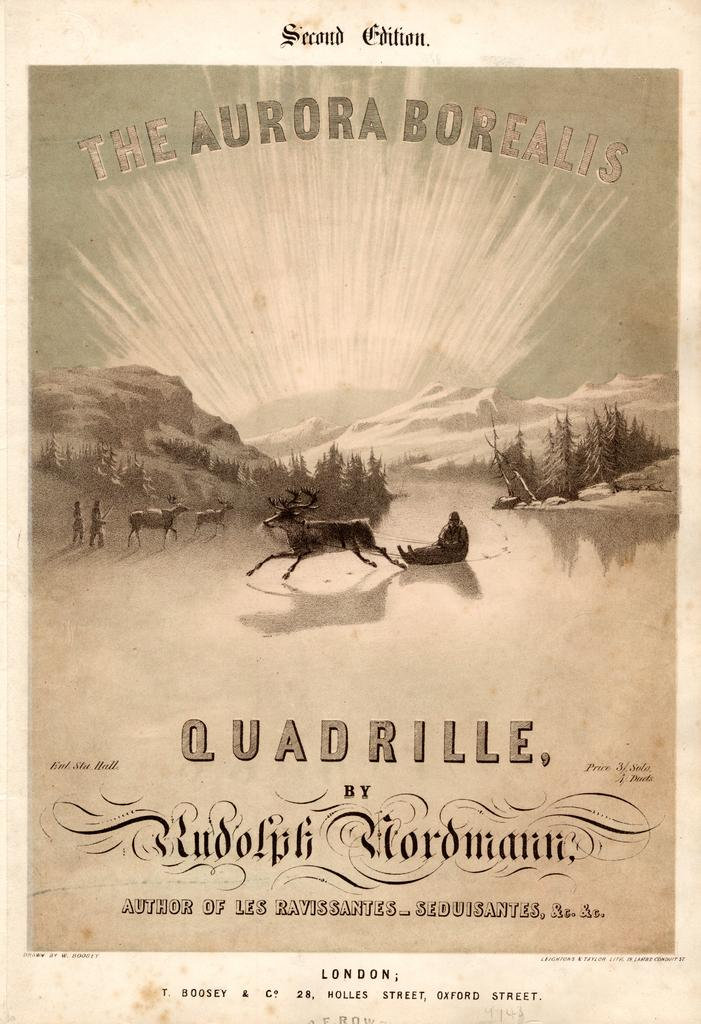Provide a one-sentence caption for the provided image. A Quadrille program with reindeer on the front page. 